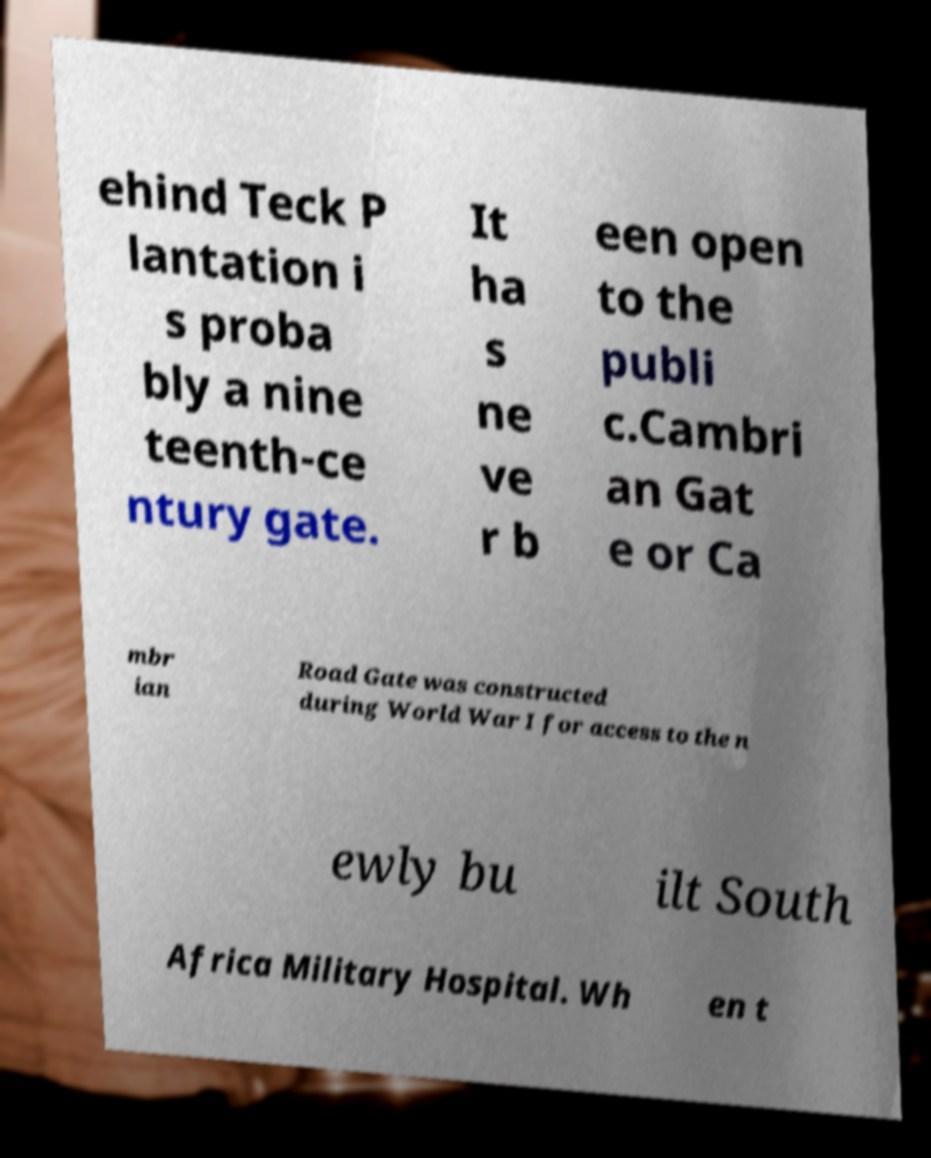Please read and relay the text visible in this image. What does it say? ehind Teck P lantation i s proba bly a nine teenth-ce ntury gate. It ha s ne ve r b een open to the publi c.Cambri an Gat e or Ca mbr ian Road Gate was constructed during World War I for access to the n ewly bu ilt South Africa Military Hospital. Wh en t 